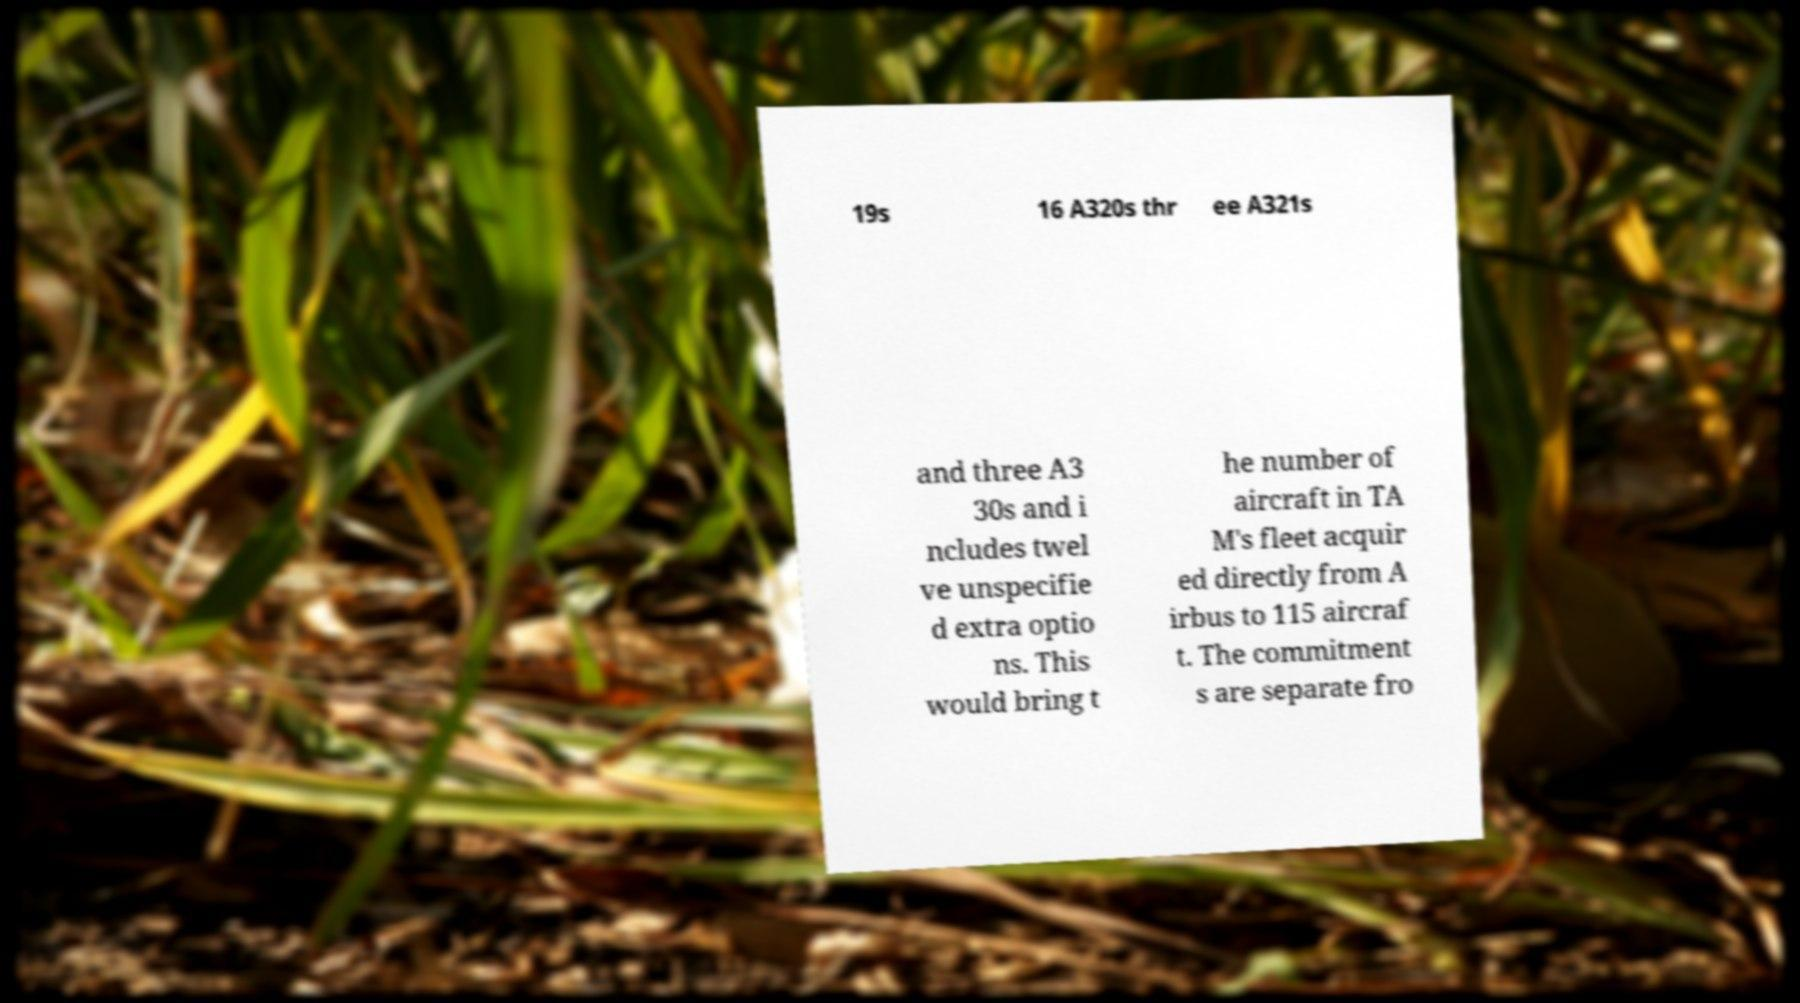Could you assist in decoding the text presented in this image and type it out clearly? 19s 16 A320s thr ee A321s and three A3 30s and i ncludes twel ve unspecifie d extra optio ns. This would bring t he number of aircraft in TA M's fleet acquir ed directly from A irbus to 115 aircraf t. The commitment s are separate fro 